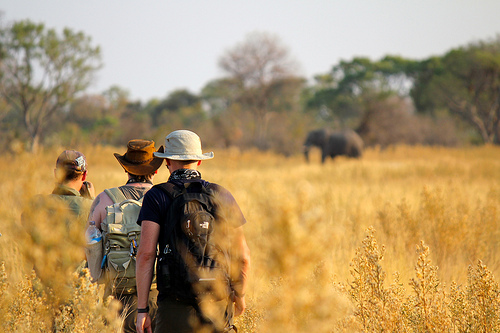Where is the elephant? The elephant is on the plain. 